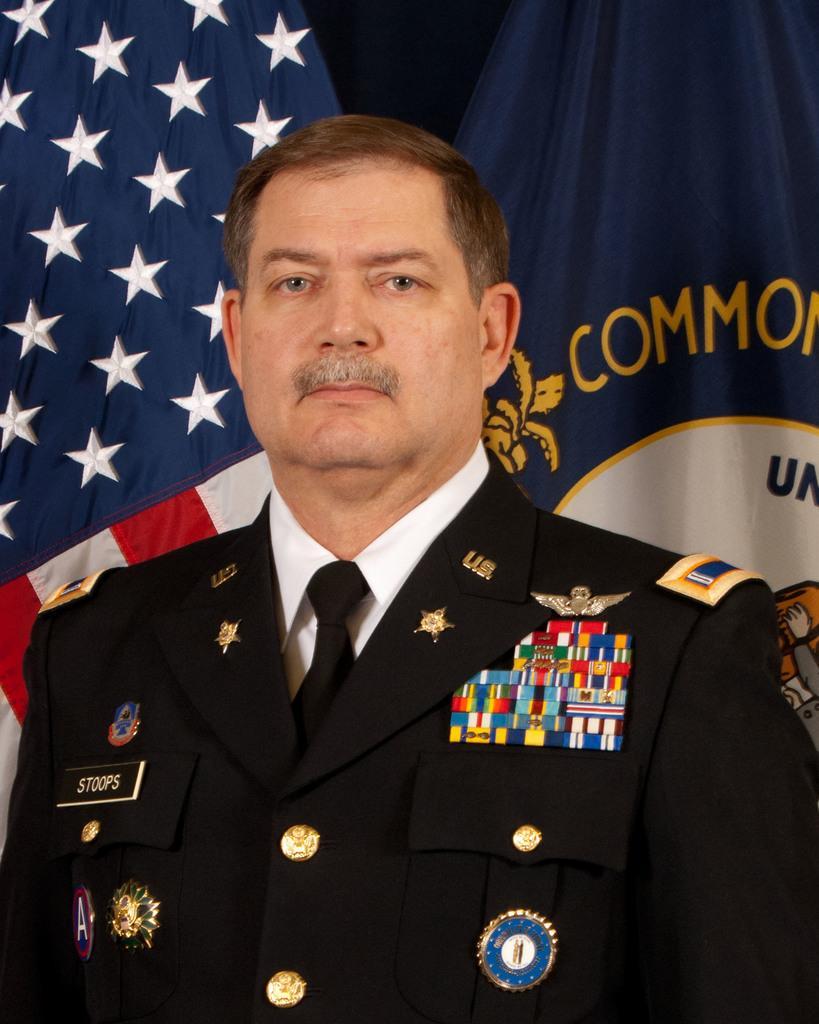In one or two sentences, can you explain what this image depicts? There is a person in black color shirt, standing. In the background, there are two flags. And the background is dark in color. 